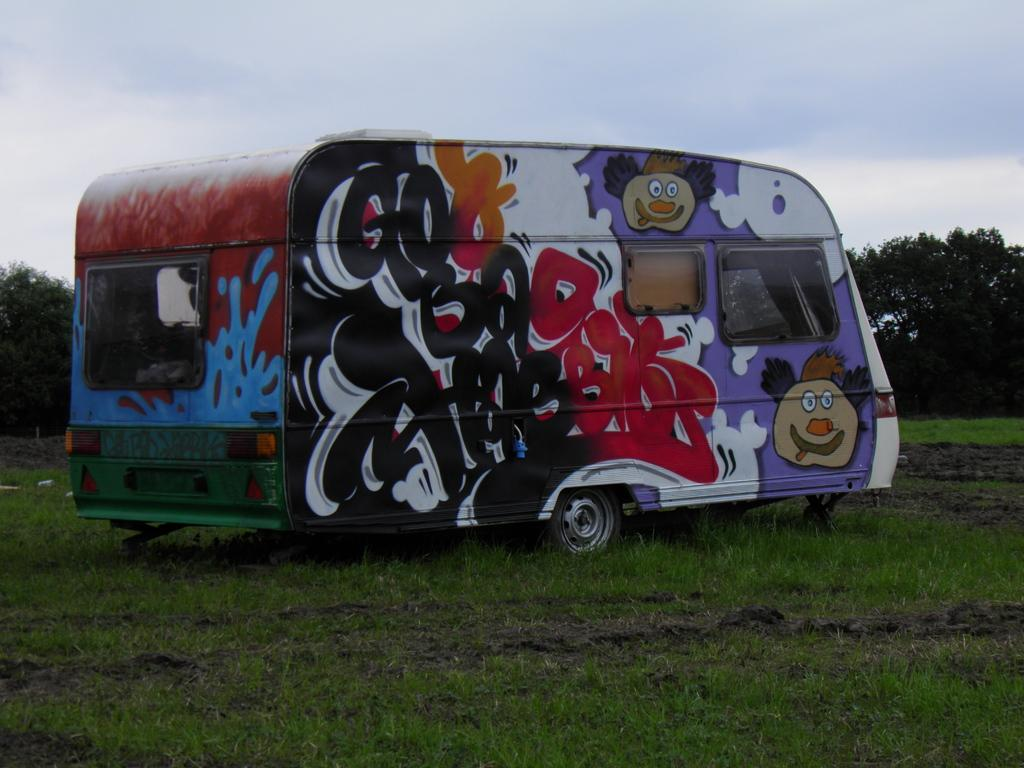What is on the ground in the image? There is a vehicle on the ground in the image. What is unique about the appearance of the vehicle? The vehicle has graffiti on it. What type of vegetation can be seen in the image? There are trees and grass in the image. What can be seen in the background of the image? The sky with clouds is visible in the background of the image. What type of lock is used to secure the vehicle in the image? There is no lock visible in the image; the vehicle has graffiti on it. What type of cord is connected to the vehicle in the image? There is no cord connected to the vehicle in the image; it is on the ground with graffiti. 